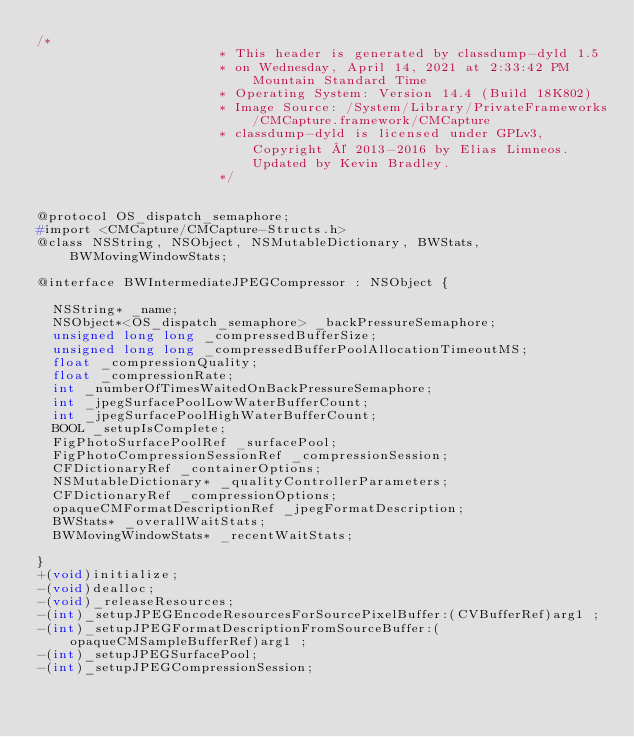Convert code to text. <code><loc_0><loc_0><loc_500><loc_500><_C_>/*
                       * This header is generated by classdump-dyld 1.5
                       * on Wednesday, April 14, 2021 at 2:33:42 PM Mountain Standard Time
                       * Operating System: Version 14.4 (Build 18K802)
                       * Image Source: /System/Library/PrivateFrameworks/CMCapture.framework/CMCapture
                       * classdump-dyld is licensed under GPLv3, Copyright © 2013-2016 by Elias Limneos. Updated by Kevin Bradley.
                       */


@protocol OS_dispatch_semaphore;
#import <CMCapture/CMCapture-Structs.h>
@class NSString, NSObject, NSMutableDictionary, BWStats, BWMovingWindowStats;

@interface BWIntermediateJPEGCompressor : NSObject {

	NSString* _name;
	NSObject*<OS_dispatch_semaphore> _backPressureSemaphore;
	unsigned long long _compressedBufferSize;
	unsigned long long _compressedBufferPoolAllocationTimeoutMS;
	float _compressionQuality;
	float _compressionRate;
	int _numberOfTimesWaitedOnBackPressureSemaphore;
	int _jpegSurfacePoolLowWaterBufferCount;
	int _jpegSurfacePoolHighWaterBufferCount;
	BOOL _setupIsComplete;
	FigPhotoSurfacePoolRef _surfacePool;
	FigPhotoCompressionSessionRef _compressionSession;
	CFDictionaryRef _containerOptions;
	NSMutableDictionary* _qualityControllerParameters;
	CFDictionaryRef _compressionOptions;
	opaqueCMFormatDescriptionRef _jpegFormatDescription;
	BWStats* _overallWaitStats;
	BWMovingWindowStats* _recentWaitStats;

}
+(void)initialize;
-(void)dealloc;
-(void)_releaseResources;
-(int)_setupJPEGEncodeResourcesForSourcePixelBuffer:(CVBufferRef)arg1 ;
-(int)_setupJPEGFormatDescriptionFromSourceBuffer:(opaqueCMSampleBufferRef)arg1 ;
-(int)_setupJPEGSurfacePool;
-(int)_setupJPEGCompressionSession;</code> 